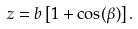Convert formula to latex. <formula><loc_0><loc_0><loc_500><loc_500>z = b \left [ 1 + \cos ( \beta ) \right ] .</formula> 